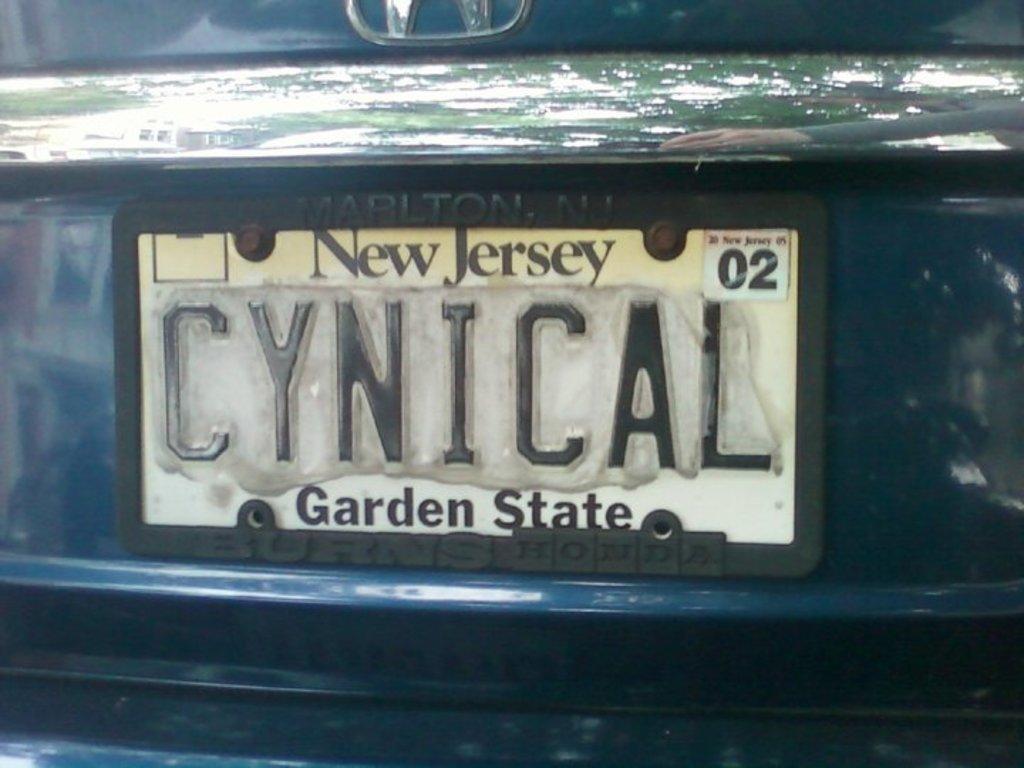How would you summarize this image in a sentence or two? In this image, we can see a board with some text. Here we can see blue color object. Top of the image, we can see metal object. Here we can see some reflections. On the right side top of the image, we can see human hand. 